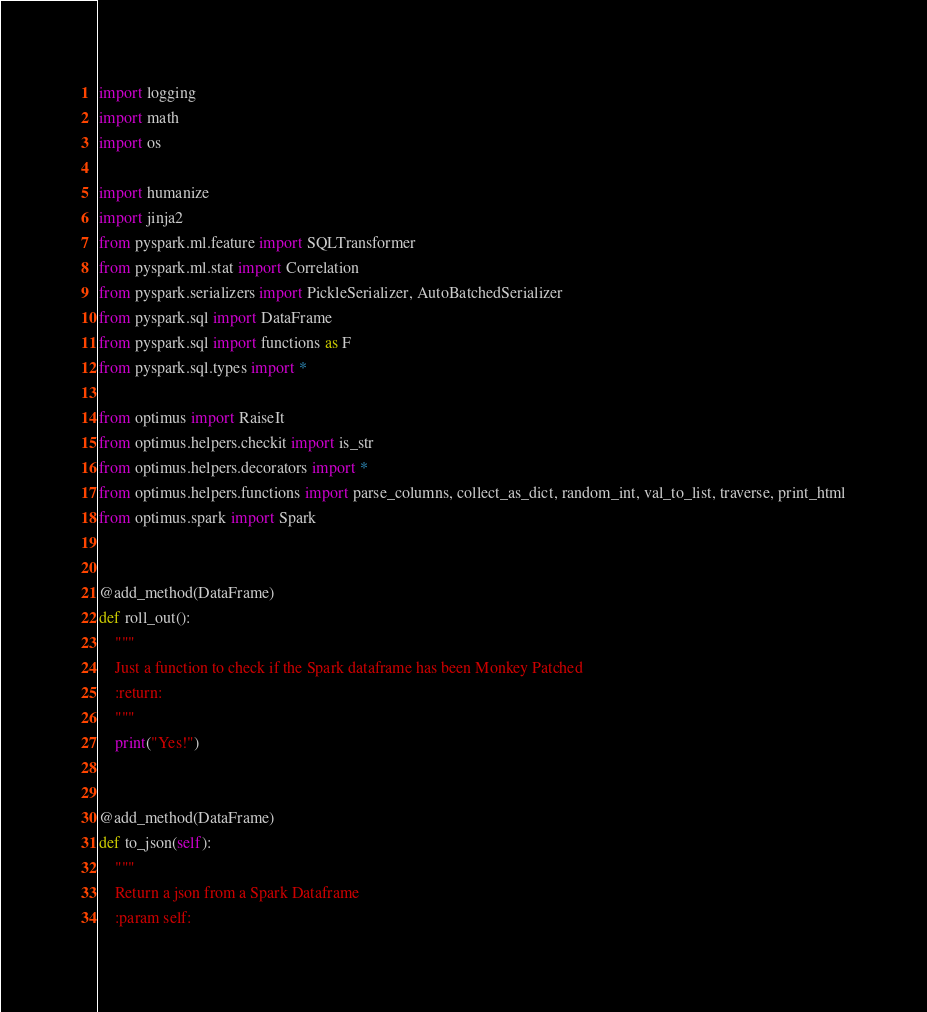Convert code to text. <code><loc_0><loc_0><loc_500><loc_500><_Python_>import logging
import math
import os

import humanize
import jinja2
from pyspark.ml.feature import SQLTransformer
from pyspark.ml.stat import Correlation
from pyspark.serializers import PickleSerializer, AutoBatchedSerializer
from pyspark.sql import DataFrame
from pyspark.sql import functions as F
from pyspark.sql.types import *

from optimus import RaiseIt
from optimus.helpers.checkit import is_str
from optimus.helpers.decorators import *
from optimus.helpers.functions import parse_columns, collect_as_dict, random_int, val_to_list, traverse, print_html
from optimus.spark import Spark


@add_method(DataFrame)
def roll_out():
    """
    Just a function to check if the Spark dataframe has been Monkey Patched
    :return:
    """
    print("Yes!")


@add_method(DataFrame)
def to_json(self):
    """
    Return a json from a Spark Dataframe
    :param self:</code> 